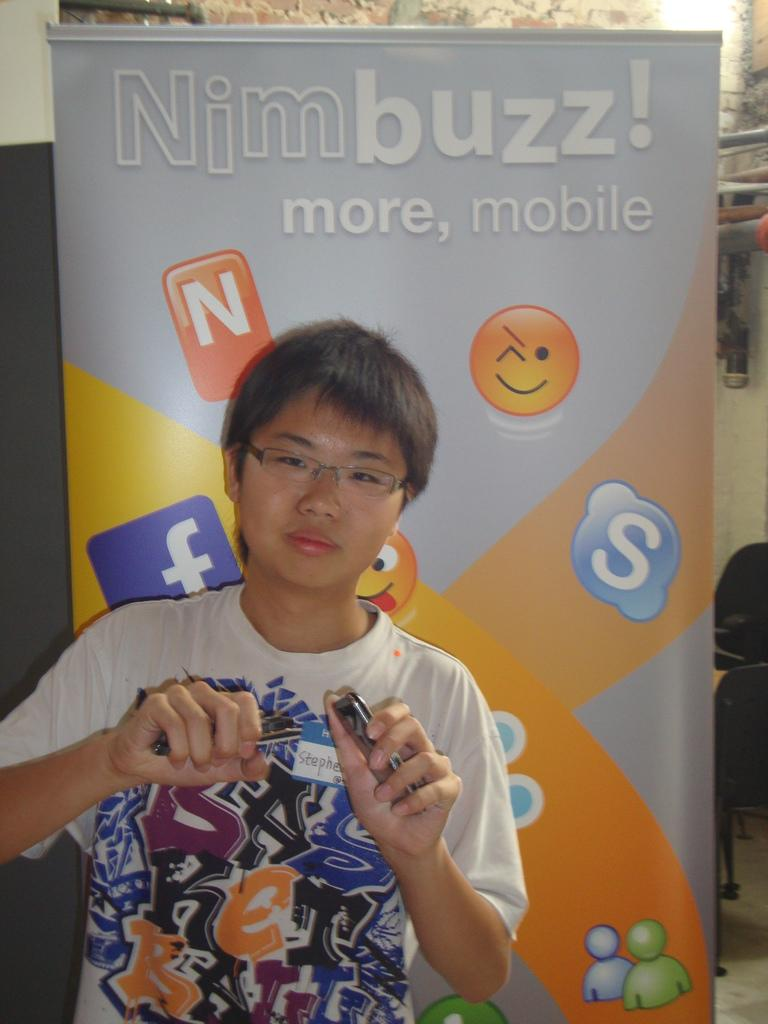<image>
Describe the image concisely. a person with the name Nim buzz on it 